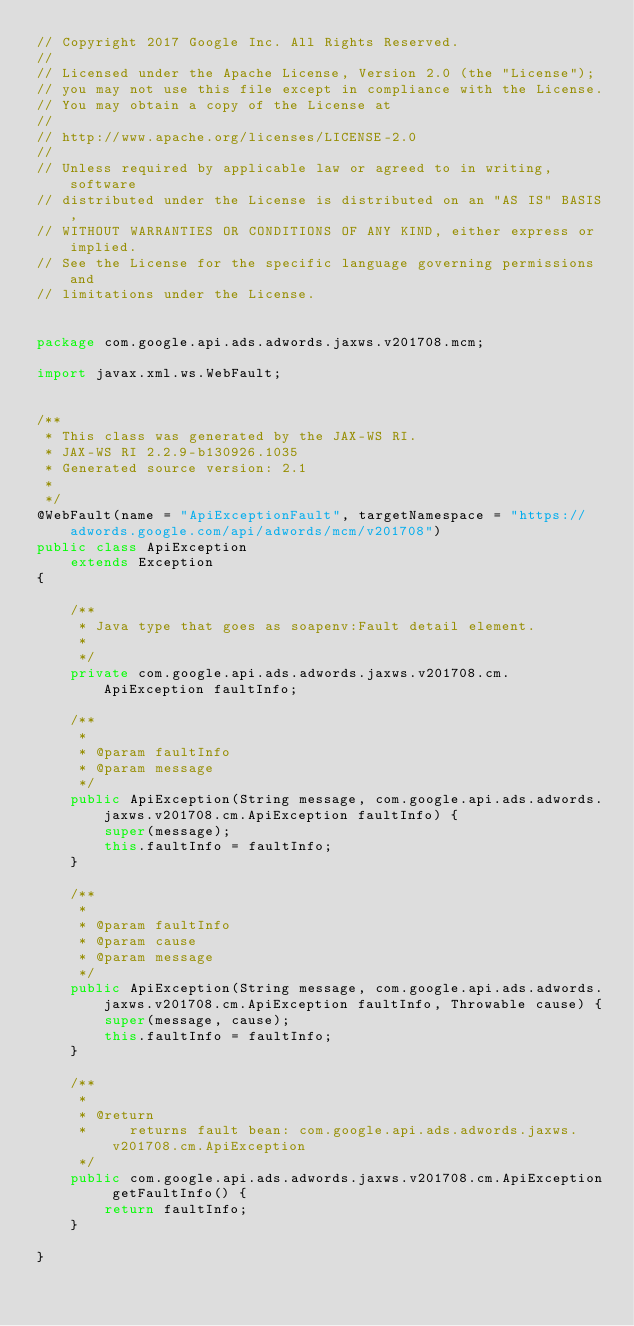<code> <loc_0><loc_0><loc_500><loc_500><_Java_>// Copyright 2017 Google Inc. All Rights Reserved.
//
// Licensed under the Apache License, Version 2.0 (the "License");
// you may not use this file except in compliance with the License.
// You may obtain a copy of the License at
//
// http://www.apache.org/licenses/LICENSE-2.0
//
// Unless required by applicable law or agreed to in writing, software
// distributed under the License is distributed on an "AS IS" BASIS,
// WITHOUT WARRANTIES OR CONDITIONS OF ANY KIND, either express or implied.
// See the License for the specific language governing permissions and
// limitations under the License.


package com.google.api.ads.adwords.jaxws.v201708.mcm;

import javax.xml.ws.WebFault;


/**
 * This class was generated by the JAX-WS RI.
 * JAX-WS RI 2.2.9-b130926.1035
 * Generated source version: 2.1
 * 
 */
@WebFault(name = "ApiExceptionFault", targetNamespace = "https://adwords.google.com/api/adwords/mcm/v201708")
public class ApiException
    extends Exception
{

    /**
     * Java type that goes as soapenv:Fault detail element.
     * 
     */
    private com.google.api.ads.adwords.jaxws.v201708.cm.ApiException faultInfo;

    /**
     * 
     * @param faultInfo
     * @param message
     */
    public ApiException(String message, com.google.api.ads.adwords.jaxws.v201708.cm.ApiException faultInfo) {
        super(message);
        this.faultInfo = faultInfo;
    }

    /**
     * 
     * @param faultInfo
     * @param cause
     * @param message
     */
    public ApiException(String message, com.google.api.ads.adwords.jaxws.v201708.cm.ApiException faultInfo, Throwable cause) {
        super(message, cause);
        this.faultInfo = faultInfo;
    }

    /**
     * 
     * @return
     *     returns fault bean: com.google.api.ads.adwords.jaxws.v201708.cm.ApiException
     */
    public com.google.api.ads.adwords.jaxws.v201708.cm.ApiException getFaultInfo() {
        return faultInfo;
    }

}
</code> 